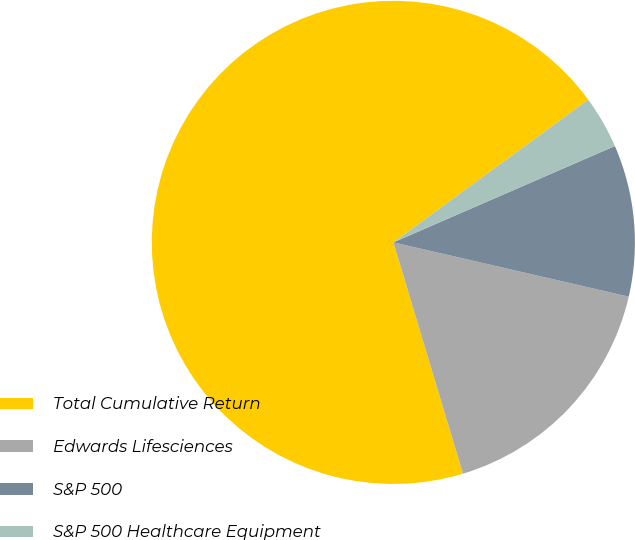Convert chart to OTSL. <chart><loc_0><loc_0><loc_500><loc_500><pie_chart><fcel>Total Cumulative Return<fcel>Edwards Lifesciences<fcel>S&P 500<fcel>S&P 500 Healthcare Equipment<nl><fcel>69.59%<fcel>16.74%<fcel>10.14%<fcel>3.53%<nl></chart> 